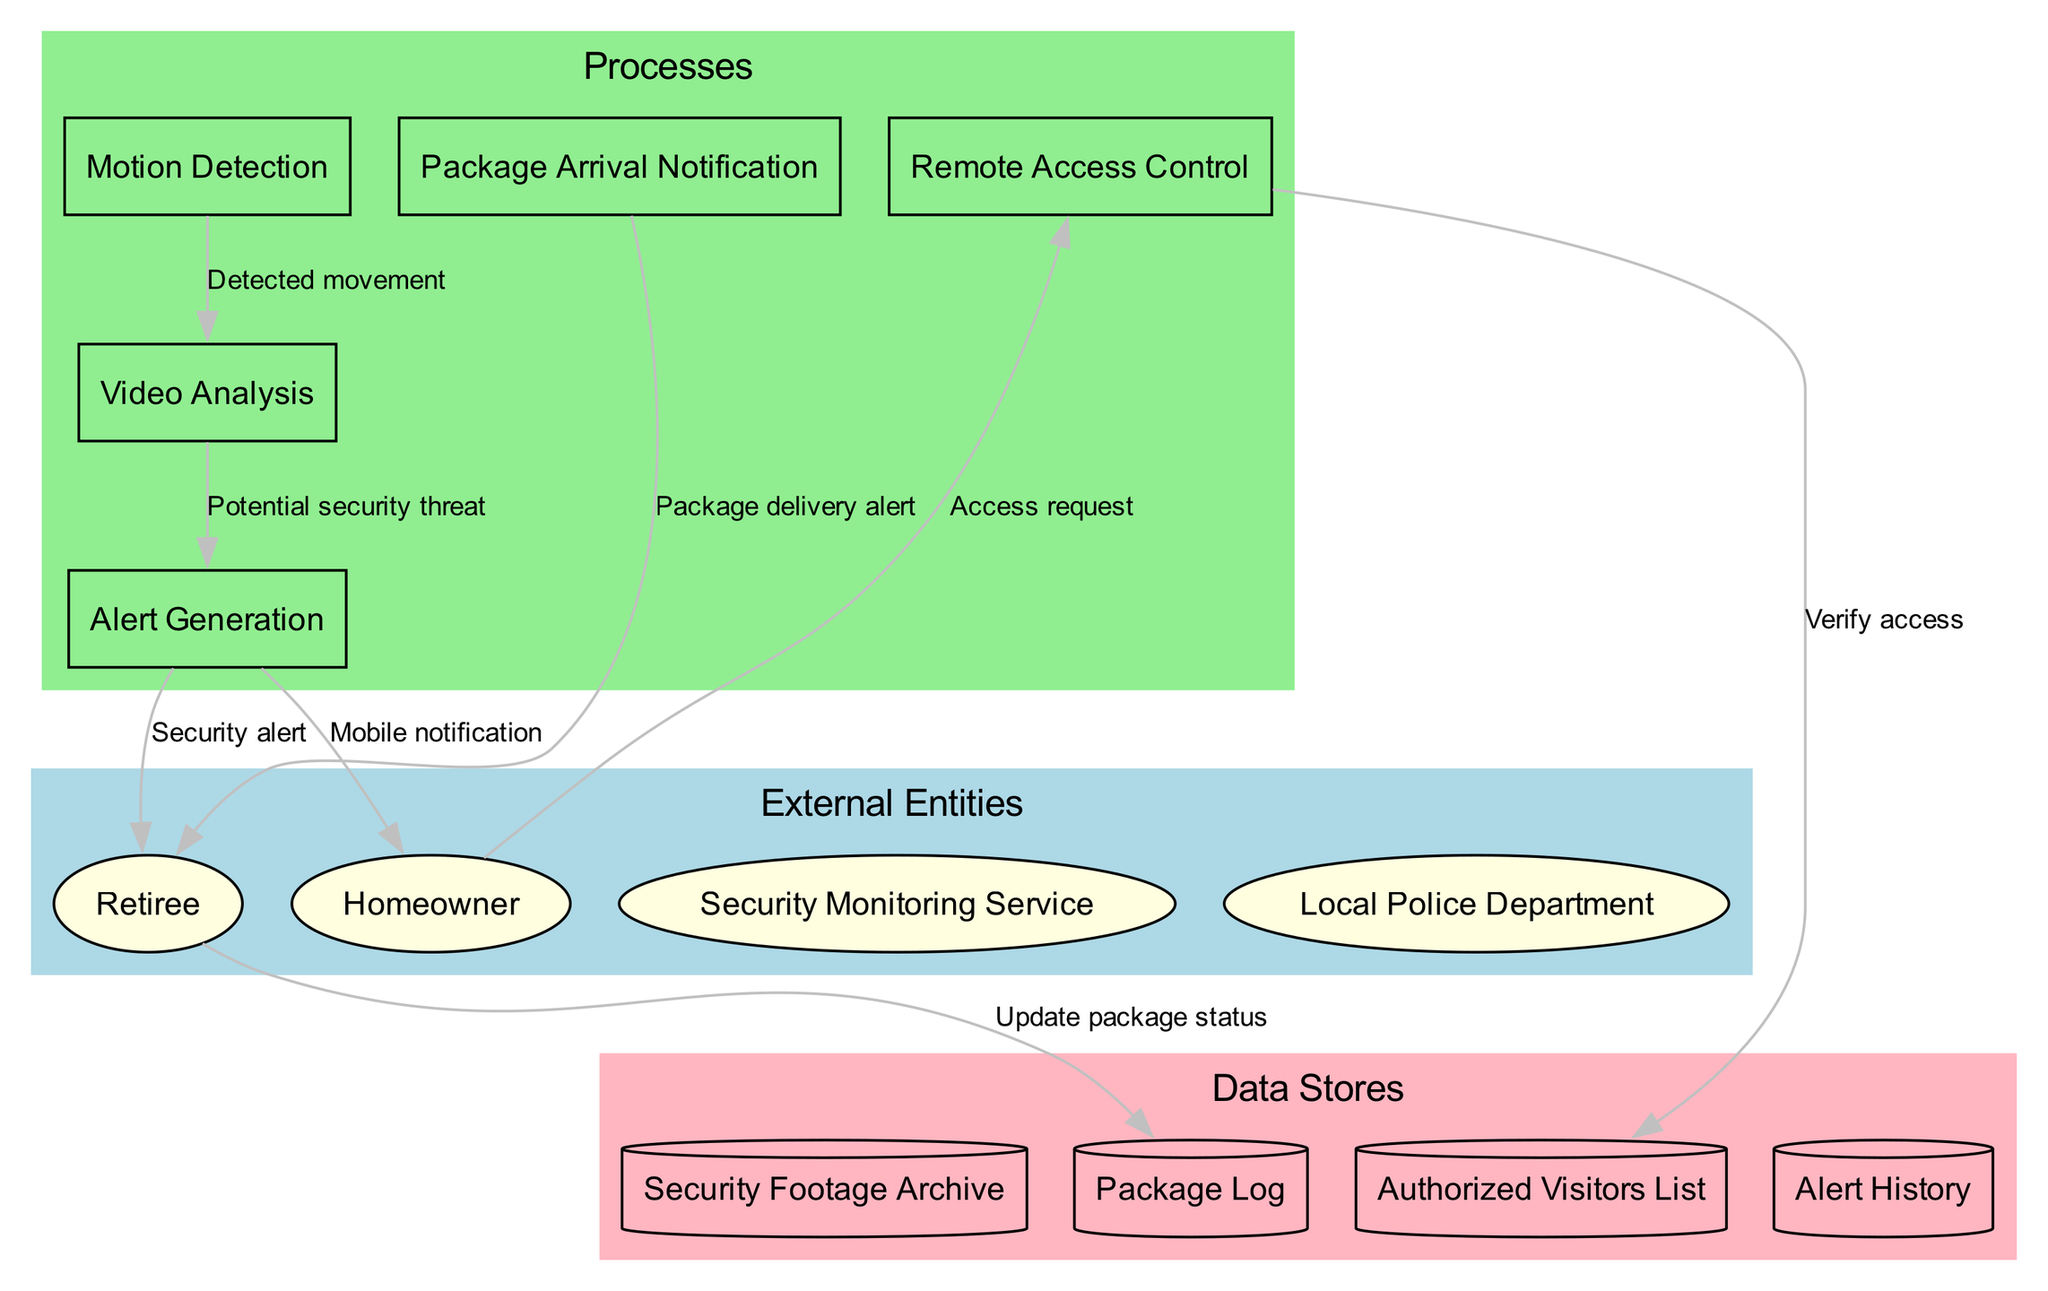What are the external entities in the diagram? The diagram includes a list of external entities: Homeowner, Retiree, Security Monitoring Service, and Local Police Department. This can be identified in the "External Entities" section of the diagram.
Answer: Homeowner, Retiree, Security Monitoring Service, Local Police Department How many processes are there in the diagram? By counting the listed processes: Motion Detection, Video Analysis, Alert Generation, Package Arrival Notification, and Remote Access Control, we find there are a total of five processes in the "Processes" section.
Answer: 5 Which process generates a security alert to the retiree? The "Alert Generation" process is the one that sends a "Security alert" to the retiree, as shown in the data flows between processes and external entities.
Answer: Alert Generation What type of notification does the homeowner receive from the Alert Generation process? The Alert Generation process provides a "Mobile notification" to the homeowner, which is indicated in the data flow description leading to the homeowner.
Answer: Mobile notification What is the relationship between Remote Access Control and the Authorized Visitors List? The Remote Access Control process verifies access to the Authorized Visitors List, as shown by the data flow connecting these two processes, illustrating a result of the access request from the homeowner.
Answer: Verify access What data flow is generated when there is a detected movement? The data flow labeled "Detected movement" occurs from the Motion Detection process to the Video Analysis process, demonstrating the initial action taken by the system upon detecting movement.
Answer: Detected movement How does the retiree update the package status? The retiree updates the package status by sending information to the Package Log process, which is represented in the data flow connecting the retiree to the package log process.
Answer: Update package status What action does the homeowner take to access the security system remotely? The homeowner initiates an "Access request" to the Remote Access Control process, indicating the user's action to establish remote access.
Answer: Access request How many data stores are present in the diagram? There are four data stores identified: Security Footage Archive, Authorized Visitors List, Package Log, and Alert History. This count includes all the unique data stores included in the diagram.
Answer: 4 